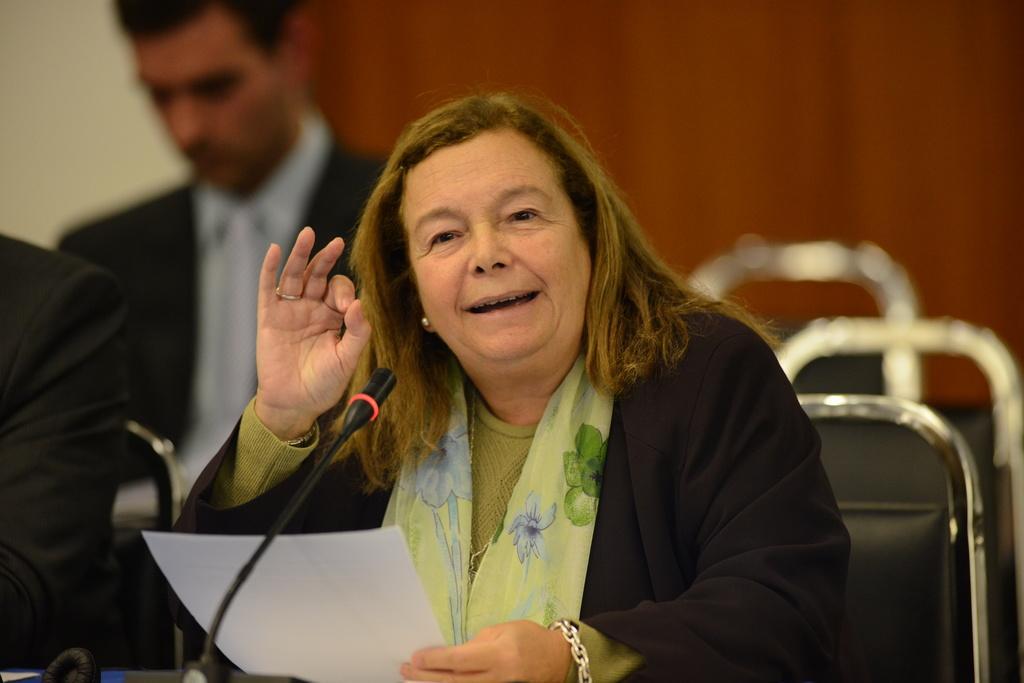Can you describe this image briefly? This image is clicked in a room. There are chairs in this image. There are three persons sitting here. The middle one is women, she has Mike in front of her and she is holding some paper. She is talking something. There is man behind her, who wore black blazer and blue color shirt. 